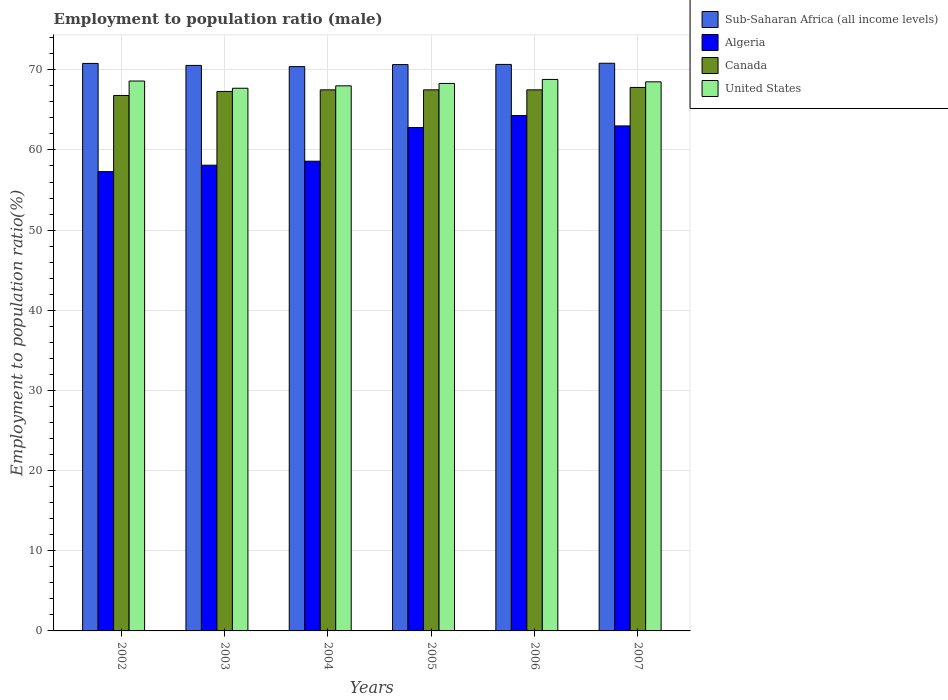How many different coloured bars are there?
Keep it short and to the point. 4. How many groups of bars are there?
Keep it short and to the point. 6. Are the number of bars on each tick of the X-axis equal?
Provide a short and direct response. Yes. How many bars are there on the 4th tick from the left?
Offer a very short reply. 4. What is the label of the 4th group of bars from the left?
Ensure brevity in your answer.  2005. What is the employment to population ratio in Algeria in 2006?
Provide a short and direct response. 64.3. Across all years, what is the maximum employment to population ratio in United States?
Offer a terse response. 68.8. Across all years, what is the minimum employment to population ratio in Algeria?
Give a very brief answer. 57.3. In which year was the employment to population ratio in United States maximum?
Offer a terse response. 2006. In which year was the employment to population ratio in United States minimum?
Give a very brief answer. 2003. What is the total employment to population ratio in Sub-Saharan Africa (all income levels) in the graph?
Make the answer very short. 423.88. What is the difference between the employment to population ratio in Sub-Saharan Africa (all income levels) in 2002 and that in 2007?
Give a very brief answer. -0.02. What is the difference between the employment to population ratio in Sub-Saharan Africa (all income levels) in 2007 and the employment to population ratio in Algeria in 2004?
Your answer should be very brief. 12.22. What is the average employment to population ratio in United States per year?
Make the answer very short. 68.32. In the year 2006, what is the difference between the employment to population ratio in United States and employment to population ratio in Canada?
Offer a terse response. 1.3. In how many years, is the employment to population ratio in Canada greater than 32 %?
Provide a succinct answer. 6. What is the ratio of the employment to population ratio in Sub-Saharan Africa (all income levels) in 2004 to that in 2007?
Offer a terse response. 0.99. Is the employment to population ratio in United States in 2005 less than that in 2007?
Your answer should be compact. Yes. What is the difference between the highest and the second highest employment to population ratio in Algeria?
Ensure brevity in your answer.  1.3. What is the difference between the highest and the lowest employment to population ratio in United States?
Offer a terse response. 1.1. Is the sum of the employment to population ratio in Canada in 2002 and 2005 greater than the maximum employment to population ratio in Sub-Saharan Africa (all income levels) across all years?
Provide a succinct answer. Yes. Is it the case that in every year, the sum of the employment to population ratio in Sub-Saharan Africa (all income levels) and employment to population ratio in Algeria is greater than the sum of employment to population ratio in United States and employment to population ratio in Canada?
Provide a short and direct response. No. Is it the case that in every year, the sum of the employment to population ratio in Sub-Saharan Africa (all income levels) and employment to population ratio in Canada is greater than the employment to population ratio in Algeria?
Your answer should be compact. Yes. What is the difference between two consecutive major ticks on the Y-axis?
Your response must be concise. 10. Does the graph contain any zero values?
Offer a terse response. No. Where does the legend appear in the graph?
Offer a very short reply. Top right. How many legend labels are there?
Ensure brevity in your answer.  4. What is the title of the graph?
Offer a terse response. Employment to population ratio (male). What is the label or title of the X-axis?
Your answer should be very brief. Years. What is the label or title of the Y-axis?
Offer a very short reply. Employment to population ratio(%). What is the Employment to population ratio(%) in Sub-Saharan Africa (all income levels) in 2002?
Provide a short and direct response. 70.8. What is the Employment to population ratio(%) in Algeria in 2002?
Offer a terse response. 57.3. What is the Employment to population ratio(%) of Canada in 2002?
Offer a terse response. 66.8. What is the Employment to population ratio(%) in United States in 2002?
Provide a short and direct response. 68.6. What is the Employment to population ratio(%) of Sub-Saharan Africa (all income levels) in 2003?
Ensure brevity in your answer.  70.55. What is the Employment to population ratio(%) in Algeria in 2003?
Make the answer very short. 58.1. What is the Employment to population ratio(%) in Canada in 2003?
Provide a short and direct response. 67.3. What is the Employment to population ratio(%) in United States in 2003?
Offer a terse response. 67.7. What is the Employment to population ratio(%) in Sub-Saharan Africa (all income levels) in 2004?
Give a very brief answer. 70.4. What is the Employment to population ratio(%) of Algeria in 2004?
Give a very brief answer. 58.6. What is the Employment to population ratio(%) in Canada in 2004?
Offer a very short reply. 67.5. What is the Employment to population ratio(%) of United States in 2004?
Keep it short and to the point. 68. What is the Employment to population ratio(%) of Sub-Saharan Africa (all income levels) in 2005?
Provide a short and direct response. 70.65. What is the Employment to population ratio(%) in Algeria in 2005?
Offer a very short reply. 62.8. What is the Employment to population ratio(%) of Canada in 2005?
Offer a very short reply. 67.5. What is the Employment to population ratio(%) in United States in 2005?
Make the answer very short. 68.3. What is the Employment to population ratio(%) of Sub-Saharan Africa (all income levels) in 2006?
Provide a succinct answer. 70.67. What is the Employment to population ratio(%) in Algeria in 2006?
Ensure brevity in your answer.  64.3. What is the Employment to population ratio(%) in Canada in 2006?
Offer a very short reply. 67.5. What is the Employment to population ratio(%) of United States in 2006?
Offer a very short reply. 68.8. What is the Employment to population ratio(%) in Sub-Saharan Africa (all income levels) in 2007?
Your response must be concise. 70.82. What is the Employment to population ratio(%) in Algeria in 2007?
Your answer should be compact. 63. What is the Employment to population ratio(%) of Canada in 2007?
Give a very brief answer. 67.8. What is the Employment to population ratio(%) of United States in 2007?
Your answer should be compact. 68.5. Across all years, what is the maximum Employment to population ratio(%) of Sub-Saharan Africa (all income levels)?
Provide a succinct answer. 70.82. Across all years, what is the maximum Employment to population ratio(%) of Algeria?
Your answer should be very brief. 64.3. Across all years, what is the maximum Employment to population ratio(%) of Canada?
Your answer should be compact. 67.8. Across all years, what is the maximum Employment to population ratio(%) in United States?
Offer a very short reply. 68.8. Across all years, what is the minimum Employment to population ratio(%) of Sub-Saharan Africa (all income levels)?
Provide a short and direct response. 70.4. Across all years, what is the minimum Employment to population ratio(%) in Algeria?
Make the answer very short. 57.3. Across all years, what is the minimum Employment to population ratio(%) in Canada?
Your response must be concise. 66.8. Across all years, what is the minimum Employment to population ratio(%) in United States?
Give a very brief answer. 67.7. What is the total Employment to population ratio(%) in Sub-Saharan Africa (all income levels) in the graph?
Provide a short and direct response. 423.88. What is the total Employment to population ratio(%) in Algeria in the graph?
Make the answer very short. 364.1. What is the total Employment to population ratio(%) in Canada in the graph?
Your answer should be very brief. 404.4. What is the total Employment to population ratio(%) in United States in the graph?
Give a very brief answer. 409.9. What is the difference between the Employment to population ratio(%) in Sub-Saharan Africa (all income levels) in 2002 and that in 2003?
Your answer should be compact. 0.25. What is the difference between the Employment to population ratio(%) of Canada in 2002 and that in 2003?
Provide a succinct answer. -0.5. What is the difference between the Employment to population ratio(%) in Sub-Saharan Africa (all income levels) in 2002 and that in 2004?
Your response must be concise. 0.4. What is the difference between the Employment to population ratio(%) of United States in 2002 and that in 2004?
Offer a terse response. 0.6. What is the difference between the Employment to population ratio(%) of Sub-Saharan Africa (all income levels) in 2002 and that in 2005?
Your answer should be compact. 0.14. What is the difference between the Employment to population ratio(%) of Algeria in 2002 and that in 2005?
Give a very brief answer. -5.5. What is the difference between the Employment to population ratio(%) of Canada in 2002 and that in 2005?
Provide a succinct answer. -0.7. What is the difference between the Employment to population ratio(%) in United States in 2002 and that in 2005?
Your answer should be very brief. 0.3. What is the difference between the Employment to population ratio(%) of Sub-Saharan Africa (all income levels) in 2002 and that in 2006?
Your response must be concise. 0.12. What is the difference between the Employment to population ratio(%) in Sub-Saharan Africa (all income levels) in 2002 and that in 2007?
Give a very brief answer. -0.02. What is the difference between the Employment to population ratio(%) in Algeria in 2002 and that in 2007?
Give a very brief answer. -5.7. What is the difference between the Employment to population ratio(%) of Canada in 2002 and that in 2007?
Provide a succinct answer. -1. What is the difference between the Employment to population ratio(%) of Canada in 2003 and that in 2004?
Keep it short and to the point. -0.2. What is the difference between the Employment to population ratio(%) in Sub-Saharan Africa (all income levels) in 2003 and that in 2005?
Keep it short and to the point. -0.1. What is the difference between the Employment to population ratio(%) of Sub-Saharan Africa (all income levels) in 2003 and that in 2006?
Your answer should be compact. -0.12. What is the difference between the Employment to population ratio(%) of Algeria in 2003 and that in 2006?
Ensure brevity in your answer.  -6.2. What is the difference between the Employment to population ratio(%) of Sub-Saharan Africa (all income levels) in 2003 and that in 2007?
Offer a terse response. -0.27. What is the difference between the Employment to population ratio(%) of Algeria in 2003 and that in 2007?
Your response must be concise. -4.9. What is the difference between the Employment to population ratio(%) in Canada in 2003 and that in 2007?
Provide a short and direct response. -0.5. What is the difference between the Employment to population ratio(%) of Sub-Saharan Africa (all income levels) in 2004 and that in 2005?
Your response must be concise. -0.25. What is the difference between the Employment to population ratio(%) in Algeria in 2004 and that in 2005?
Ensure brevity in your answer.  -4.2. What is the difference between the Employment to population ratio(%) in United States in 2004 and that in 2005?
Offer a very short reply. -0.3. What is the difference between the Employment to population ratio(%) of Sub-Saharan Africa (all income levels) in 2004 and that in 2006?
Provide a short and direct response. -0.27. What is the difference between the Employment to population ratio(%) in Algeria in 2004 and that in 2006?
Offer a terse response. -5.7. What is the difference between the Employment to population ratio(%) of Canada in 2004 and that in 2006?
Provide a short and direct response. 0. What is the difference between the Employment to population ratio(%) in United States in 2004 and that in 2006?
Keep it short and to the point. -0.8. What is the difference between the Employment to population ratio(%) of Sub-Saharan Africa (all income levels) in 2004 and that in 2007?
Keep it short and to the point. -0.42. What is the difference between the Employment to population ratio(%) in Algeria in 2004 and that in 2007?
Give a very brief answer. -4.4. What is the difference between the Employment to population ratio(%) in Canada in 2004 and that in 2007?
Give a very brief answer. -0.3. What is the difference between the Employment to population ratio(%) in United States in 2004 and that in 2007?
Offer a very short reply. -0.5. What is the difference between the Employment to population ratio(%) of Sub-Saharan Africa (all income levels) in 2005 and that in 2006?
Your answer should be compact. -0.02. What is the difference between the Employment to population ratio(%) in Algeria in 2005 and that in 2006?
Give a very brief answer. -1.5. What is the difference between the Employment to population ratio(%) in United States in 2005 and that in 2006?
Keep it short and to the point. -0.5. What is the difference between the Employment to population ratio(%) in Sub-Saharan Africa (all income levels) in 2005 and that in 2007?
Make the answer very short. -0.17. What is the difference between the Employment to population ratio(%) in Sub-Saharan Africa (all income levels) in 2006 and that in 2007?
Provide a short and direct response. -0.15. What is the difference between the Employment to population ratio(%) of Canada in 2006 and that in 2007?
Keep it short and to the point. -0.3. What is the difference between the Employment to population ratio(%) in United States in 2006 and that in 2007?
Your answer should be very brief. 0.3. What is the difference between the Employment to population ratio(%) in Sub-Saharan Africa (all income levels) in 2002 and the Employment to population ratio(%) in Algeria in 2003?
Ensure brevity in your answer.  12.7. What is the difference between the Employment to population ratio(%) in Sub-Saharan Africa (all income levels) in 2002 and the Employment to population ratio(%) in Canada in 2003?
Offer a very short reply. 3.5. What is the difference between the Employment to population ratio(%) in Sub-Saharan Africa (all income levels) in 2002 and the Employment to population ratio(%) in United States in 2003?
Provide a short and direct response. 3.1. What is the difference between the Employment to population ratio(%) of Canada in 2002 and the Employment to population ratio(%) of United States in 2003?
Ensure brevity in your answer.  -0.9. What is the difference between the Employment to population ratio(%) of Sub-Saharan Africa (all income levels) in 2002 and the Employment to population ratio(%) of Algeria in 2004?
Your answer should be very brief. 12.2. What is the difference between the Employment to population ratio(%) of Sub-Saharan Africa (all income levels) in 2002 and the Employment to population ratio(%) of Canada in 2004?
Provide a succinct answer. 3.3. What is the difference between the Employment to population ratio(%) in Sub-Saharan Africa (all income levels) in 2002 and the Employment to population ratio(%) in United States in 2004?
Offer a very short reply. 2.8. What is the difference between the Employment to population ratio(%) in Canada in 2002 and the Employment to population ratio(%) in United States in 2004?
Offer a very short reply. -1.2. What is the difference between the Employment to population ratio(%) in Sub-Saharan Africa (all income levels) in 2002 and the Employment to population ratio(%) in Algeria in 2005?
Your answer should be compact. 8. What is the difference between the Employment to population ratio(%) of Sub-Saharan Africa (all income levels) in 2002 and the Employment to population ratio(%) of Canada in 2005?
Keep it short and to the point. 3.3. What is the difference between the Employment to population ratio(%) in Sub-Saharan Africa (all income levels) in 2002 and the Employment to population ratio(%) in United States in 2005?
Your response must be concise. 2.5. What is the difference between the Employment to population ratio(%) in Algeria in 2002 and the Employment to population ratio(%) in Canada in 2005?
Give a very brief answer. -10.2. What is the difference between the Employment to population ratio(%) of Algeria in 2002 and the Employment to population ratio(%) of United States in 2005?
Provide a short and direct response. -11. What is the difference between the Employment to population ratio(%) of Canada in 2002 and the Employment to population ratio(%) of United States in 2005?
Ensure brevity in your answer.  -1.5. What is the difference between the Employment to population ratio(%) in Sub-Saharan Africa (all income levels) in 2002 and the Employment to population ratio(%) in Algeria in 2006?
Your response must be concise. 6.5. What is the difference between the Employment to population ratio(%) in Sub-Saharan Africa (all income levels) in 2002 and the Employment to population ratio(%) in Canada in 2006?
Make the answer very short. 3.3. What is the difference between the Employment to population ratio(%) in Sub-Saharan Africa (all income levels) in 2002 and the Employment to population ratio(%) in United States in 2006?
Offer a very short reply. 2. What is the difference between the Employment to population ratio(%) in Algeria in 2002 and the Employment to population ratio(%) in Canada in 2006?
Your response must be concise. -10.2. What is the difference between the Employment to population ratio(%) of Canada in 2002 and the Employment to population ratio(%) of United States in 2006?
Give a very brief answer. -2. What is the difference between the Employment to population ratio(%) of Sub-Saharan Africa (all income levels) in 2002 and the Employment to population ratio(%) of Algeria in 2007?
Provide a succinct answer. 7.8. What is the difference between the Employment to population ratio(%) in Sub-Saharan Africa (all income levels) in 2002 and the Employment to population ratio(%) in Canada in 2007?
Offer a terse response. 3. What is the difference between the Employment to population ratio(%) in Sub-Saharan Africa (all income levels) in 2002 and the Employment to population ratio(%) in United States in 2007?
Your answer should be compact. 2.3. What is the difference between the Employment to population ratio(%) in Algeria in 2002 and the Employment to population ratio(%) in Canada in 2007?
Keep it short and to the point. -10.5. What is the difference between the Employment to population ratio(%) of Canada in 2002 and the Employment to population ratio(%) of United States in 2007?
Your answer should be very brief. -1.7. What is the difference between the Employment to population ratio(%) of Sub-Saharan Africa (all income levels) in 2003 and the Employment to population ratio(%) of Algeria in 2004?
Your answer should be very brief. 11.95. What is the difference between the Employment to population ratio(%) of Sub-Saharan Africa (all income levels) in 2003 and the Employment to population ratio(%) of Canada in 2004?
Make the answer very short. 3.05. What is the difference between the Employment to population ratio(%) of Sub-Saharan Africa (all income levels) in 2003 and the Employment to population ratio(%) of United States in 2004?
Keep it short and to the point. 2.55. What is the difference between the Employment to population ratio(%) in Algeria in 2003 and the Employment to population ratio(%) in Canada in 2004?
Your answer should be very brief. -9.4. What is the difference between the Employment to population ratio(%) of Canada in 2003 and the Employment to population ratio(%) of United States in 2004?
Offer a terse response. -0.7. What is the difference between the Employment to population ratio(%) of Sub-Saharan Africa (all income levels) in 2003 and the Employment to population ratio(%) of Algeria in 2005?
Your answer should be very brief. 7.75. What is the difference between the Employment to population ratio(%) of Sub-Saharan Africa (all income levels) in 2003 and the Employment to population ratio(%) of Canada in 2005?
Your answer should be very brief. 3.05. What is the difference between the Employment to population ratio(%) of Sub-Saharan Africa (all income levels) in 2003 and the Employment to population ratio(%) of United States in 2005?
Provide a succinct answer. 2.25. What is the difference between the Employment to population ratio(%) of Sub-Saharan Africa (all income levels) in 2003 and the Employment to population ratio(%) of Algeria in 2006?
Your answer should be compact. 6.25. What is the difference between the Employment to population ratio(%) of Sub-Saharan Africa (all income levels) in 2003 and the Employment to population ratio(%) of Canada in 2006?
Your response must be concise. 3.05. What is the difference between the Employment to population ratio(%) in Sub-Saharan Africa (all income levels) in 2003 and the Employment to population ratio(%) in United States in 2006?
Ensure brevity in your answer.  1.75. What is the difference between the Employment to population ratio(%) of Algeria in 2003 and the Employment to population ratio(%) of Canada in 2006?
Give a very brief answer. -9.4. What is the difference between the Employment to population ratio(%) of Algeria in 2003 and the Employment to population ratio(%) of United States in 2006?
Keep it short and to the point. -10.7. What is the difference between the Employment to population ratio(%) in Sub-Saharan Africa (all income levels) in 2003 and the Employment to population ratio(%) in Algeria in 2007?
Provide a short and direct response. 7.55. What is the difference between the Employment to population ratio(%) of Sub-Saharan Africa (all income levels) in 2003 and the Employment to population ratio(%) of Canada in 2007?
Provide a short and direct response. 2.75. What is the difference between the Employment to population ratio(%) of Sub-Saharan Africa (all income levels) in 2003 and the Employment to population ratio(%) of United States in 2007?
Make the answer very short. 2.05. What is the difference between the Employment to population ratio(%) of Canada in 2003 and the Employment to population ratio(%) of United States in 2007?
Your answer should be compact. -1.2. What is the difference between the Employment to population ratio(%) in Sub-Saharan Africa (all income levels) in 2004 and the Employment to population ratio(%) in Algeria in 2005?
Offer a very short reply. 7.6. What is the difference between the Employment to population ratio(%) of Sub-Saharan Africa (all income levels) in 2004 and the Employment to population ratio(%) of Canada in 2005?
Keep it short and to the point. 2.9. What is the difference between the Employment to population ratio(%) in Sub-Saharan Africa (all income levels) in 2004 and the Employment to population ratio(%) in United States in 2005?
Offer a very short reply. 2.1. What is the difference between the Employment to population ratio(%) of Algeria in 2004 and the Employment to population ratio(%) of United States in 2005?
Offer a terse response. -9.7. What is the difference between the Employment to population ratio(%) in Sub-Saharan Africa (all income levels) in 2004 and the Employment to population ratio(%) in Algeria in 2006?
Offer a terse response. 6.1. What is the difference between the Employment to population ratio(%) in Sub-Saharan Africa (all income levels) in 2004 and the Employment to population ratio(%) in Canada in 2006?
Provide a succinct answer. 2.9. What is the difference between the Employment to population ratio(%) in Sub-Saharan Africa (all income levels) in 2004 and the Employment to population ratio(%) in United States in 2006?
Make the answer very short. 1.6. What is the difference between the Employment to population ratio(%) of Algeria in 2004 and the Employment to population ratio(%) of Canada in 2006?
Offer a terse response. -8.9. What is the difference between the Employment to population ratio(%) of Sub-Saharan Africa (all income levels) in 2004 and the Employment to population ratio(%) of Algeria in 2007?
Offer a very short reply. 7.4. What is the difference between the Employment to population ratio(%) of Sub-Saharan Africa (all income levels) in 2004 and the Employment to population ratio(%) of Canada in 2007?
Keep it short and to the point. 2.6. What is the difference between the Employment to population ratio(%) in Sub-Saharan Africa (all income levels) in 2004 and the Employment to population ratio(%) in United States in 2007?
Give a very brief answer. 1.9. What is the difference between the Employment to population ratio(%) in Algeria in 2004 and the Employment to population ratio(%) in Canada in 2007?
Ensure brevity in your answer.  -9.2. What is the difference between the Employment to population ratio(%) in Canada in 2004 and the Employment to population ratio(%) in United States in 2007?
Your answer should be very brief. -1. What is the difference between the Employment to population ratio(%) of Sub-Saharan Africa (all income levels) in 2005 and the Employment to population ratio(%) of Algeria in 2006?
Provide a short and direct response. 6.35. What is the difference between the Employment to population ratio(%) of Sub-Saharan Africa (all income levels) in 2005 and the Employment to population ratio(%) of Canada in 2006?
Ensure brevity in your answer.  3.15. What is the difference between the Employment to population ratio(%) of Sub-Saharan Africa (all income levels) in 2005 and the Employment to population ratio(%) of United States in 2006?
Give a very brief answer. 1.85. What is the difference between the Employment to population ratio(%) in Algeria in 2005 and the Employment to population ratio(%) in Canada in 2006?
Your response must be concise. -4.7. What is the difference between the Employment to population ratio(%) in Sub-Saharan Africa (all income levels) in 2005 and the Employment to population ratio(%) in Algeria in 2007?
Ensure brevity in your answer.  7.65. What is the difference between the Employment to population ratio(%) of Sub-Saharan Africa (all income levels) in 2005 and the Employment to population ratio(%) of Canada in 2007?
Make the answer very short. 2.85. What is the difference between the Employment to population ratio(%) of Sub-Saharan Africa (all income levels) in 2005 and the Employment to population ratio(%) of United States in 2007?
Ensure brevity in your answer.  2.15. What is the difference between the Employment to population ratio(%) in Canada in 2005 and the Employment to population ratio(%) in United States in 2007?
Provide a short and direct response. -1. What is the difference between the Employment to population ratio(%) of Sub-Saharan Africa (all income levels) in 2006 and the Employment to population ratio(%) of Algeria in 2007?
Provide a succinct answer. 7.67. What is the difference between the Employment to population ratio(%) in Sub-Saharan Africa (all income levels) in 2006 and the Employment to population ratio(%) in Canada in 2007?
Offer a very short reply. 2.87. What is the difference between the Employment to population ratio(%) of Sub-Saharan Africa (all income levels) in 2006 and the Employment to population ratio(%) of United States in 2007?
Keep it short and to the point. 2.17. What is the difference between the Employment to population ratio(%) of Algeria in 2006 and the Employment to population ratio(%) of Canada in 2007?
Make the answer very short. -3.5. What is the difference between the Employment to population ratio(%) of Canada in 2006 and the Employment to population ratio(%) of United States in 2007?
Ensure brevity in your answer.  -1. What is the average Employment to population ratio(%) in Sub-Saharan Africa (all income levels) per year?
Provide a short and direct response. 70.65. What is the average Employment to population ratio(%) in Algeria per year?
Your answer should be very brief. 60.68. What is the average Employment to population ratio(%) in Canada per year?
Make the answer very short. 67.4. What is the average Employment to population ratio(%) in United States per year?
Make the answer very short. 68.32. In the year 2002, what is the difference between the Employment to population ratio(%) of Sub-Saharan Africa (all income levels) and Employment to population ratio(%) of Algeria?
Keep it short and to the point. 13.5. In the year 2002, what is the difference between the Employment to population ratio(%) in Sub-Saharan Africa (all income levels) and Employment to population ratio(%) in Canada?
Ensure brevity in your answer.  4. In the year 2002, what is the difference between the Employment to population ratio(%) of Sub-Saharan Africa (all income levels) and Employment to population ratio(%) of United States?
Provide a short and direct response. 2.2. In the year 2002, what is the difference between the Employment to population ratio(%) of Algeria and Employment to population ratio(%) of Canada?
Ensure brevity in your answer.  -9.5. In the year 2002, what is the difference between the Employment to population ratio(%) in Algeria and Employment to population ratio(%) in United States?
Make the answer very short. -11.3. In the year 2002, what is the difference between the Employment to population ratio(%) of Canada and Employment to population ratio(%) of United States?
Provide a succinct answer. -1.8. In the year 2003, what is the difference between the Employment to population ratio(%) of Sub-Saharan Africa (all income levels) and Employment to population ratio(%) of Algeria?
Your answer should be very brief. 12.45. In the year 2003, what is the difference between the Employment to population ratio(%) of Sub-Saharan Africa (all income levels) and Employment to population ratio(%) of Canada?
Offer a terse response. 3.25. In the year 2003, what is the difference between the Employment to population ratio(%) of Sub-Saharan Africa (all income levels) and Employment to population ratio(%) of United States?
Your answer should be very brief. 2.85. In the year 2003, what is the difference between the Employment to population ratio(%) in Algeria and Employment to population ratio(%) in Canada?
Your response must be concise. -9.2. In the year 2004, what is the difference between the Employment to population ratio(%) of Sub-Saharan Africa (all income levels) and Employment to population ratio(%) of Algeria?
Your response must be concise. 11.8. In the year 2004, what is the difference between the Employment to population ratio(%) in Sub-Saharan Africa (all income levels) and Employment to population ratio(%) in Canada?
Offer a terse response. 2.9. In the year 2004, what is the difference between the Employment to population ratio(%) of Sub-Saharan Africa (all income levels) and Employment to population ratio(%) of United States?
Your answer should be very brief. 2.4. In the year 2004, what is the difference between the Employment to population ratio(%) in Algeria and Employment to population ratio(%) in United States?
Provide a succinct answer. -9.4. In the year 2005, what is the difference between the Employment to population ratio(%) in Sub-Saharan Africa (all income levels) and Employment to population ratio(%) in Algeria?
Offer a very short reply. 7.85. In the year 2005, what is the difference between the Employment to population ratio(%) of Sub-Saharan Africa (all income levels) and Employment to population ratio(%) of Canada?
Offer a very short reply. 3.15. In the year 2005, what is the difference between the Employment to population ratio(%) in Sub-Saharan Africa (all income levels) and Employment to population ratio(%) in United States?
Offer a terse response. 2.35. In the year 2005, what is the difference between the Employment to population ratio(%) in Algeria and Employment to population ratio(%) in United States?
Your response must be concise. -5.5. In the year 2005, what is the difference between the Employment to population ratio(%) of Canada and Employment to population ratio(%) of United States?
Give a very brief answer. -0.8. In the year 2006, what is the difference between the Employment to population ratio(%) in Sub-Saharan Africa (all income levels) and Employment to population ratio(%) in Algeria?
Provide a short and direct response. 6.37. In the year 2006, what is the difference between the Employment to population ratio(%) of Sub-Saharan Africa (all income levels) and Employment to population ratio(%) of Canada?
Make the answer very short. 3.17. In the year 2006, what is the difference between the Employment to population ratio(%) in Sub-Saharan Africa (all income levels) and Employment to population ratio(%) in United States?
Your response must be concise. 1.87. In the year 2006, what is the difference between the Employment to population ratio(%) in Algeria and Employment to population ratio(%) in United States?
Your answer should be very brief. -4.5. In the year 2007, what is the difference between the Employment to population ratio(%) in Sub-Saharan Africa (all income levels) and Employment to population ratio(%) in Algeria?
Make the answer very short. 7.82. In the year 2007, what is the difference between the Employment to population ratio(%) of Sub-Saharan Africa (all income levels) and Employment to population ratio(%) of Canada?
Your response must be concise. 3.02. In the year 2007, what is the difference between the Employment to population ratio(%) of Sub-Saharan Africa (all income levels) and Employment to population ratio(%) of United States?
Your answer should be compact. 2.32. In the year 2007, what is the difference between the Employment to population ratio(%) of Canada and Employment to population ratio(%) of United States?
Offer a terse response. -0.7. What is the ratio of the Employment to population ratio(%) in Sub-Saharan Africa (all income levels) in 2002 to that in 2003?
Offer a very short reply. 1. What is the ratio of the Employment to population ratio(%) of Algeria in 2002 to that in 2003?
Keep it short and to the point. 0.99. What is the ratio of the Employment to population ratio(%) of Canada in 2002 to that in 2003?
Provide a short and direct response. 0.99. What is the ratio of the Employment to population ratio(%) of United States in 2002 to that in 2003?
Offer a terse response. 1.01. What is the ratio of the Employment to population ratio(%) of Sub-Saharan Africa (all income levels) in 2002 to that in 2004?
Give a very brief answer. 1.01. What is the ratio of the Employment to population ratio(%) in Algeria in 2002 to that in 2004?
Give a very brief answer. 0.98. What is the ratio of the Employment to population ratio(%) in Canada in 2002 to that in 2004?
Keep it short and to the point. 0.99. What is the ratio of the Employment to population ratio(%) in United States in 2002 to that in 2004?
Your answer should be very brief. 1.01. What is the ratio of the Employment to population ratio(%) of Sub-Saharan Africa (all income levels) in 2002 to that in 2005?
Offer a terse response. 1. What is the ratio of the Employment to population ratio(%) in Algeria in 2002 to that in 2005?
Provide a succinct answer. 0.91. What is the ratio of the Employment to population ratio(%) of Canada in 2002 to that in 2005?
Ensure brevity in your answer.  0.99. What is the ratio of the Employment to population ratio(%) in United States in 2002 to that in 2005?
Make the answer very short. 1. What is the ratio of the Employment to population ratio(%) in Sub-Saharan Africa (all income levels) in 2002 to that in 2006?
Ensure brevity in your answer.  1. What is the ratio of the Employment to population ratio(%) of Algeria in 2002 to that in 2006?
Make the answer very short. 0.89. What is the ratio of the Employment to population ratio(%) of Sub-Saharan Africa (all income levels) in 2002 to that in 2007?
Provide a short and direct response. 1. What is the ratio of the Employment to population ratio(%) in Algeria in 2002 to that in 2007?
Make the answer very short. 0.91. What is the ratio of the Employment to population ratio(%) of Sub-Saharan Africa (all income levels) in 2003 to that in 2004?
Make the answer very short. 1. What is the ratio of the Employment to population ratio(%) in Algeria in 2003 to that in 2005?
Offer a terse response. 0.93. What is the ratio of the Employment to population ratio(%) in Canada in 2003 to that in 2005?
Give a very brief answer. 1. What is the ratio of the Employment to population ratio(%) in United States in 2003 to that in 2005?
Provide a short and direct response. 0.99. What is the ratio of the Employment to population ratio(%) of Sub-Saharan Africa (all income levels) in 2003 to that in 2006?
Your answer should be very brief. 1. What is the ratio of the Employment to population ratio(%) of Algeria in 2003 to that in 2006?
Your answer should be compact. 0.9. What is the ratio of the Employment to population ratio(%) in Canada in 2003 to that in 2006?
Your answer should be very brief. 1. What is the ratio of the Employment to population ratio(%) in Algeria in 2003 to that in 2007?
Keep it short and to the point. 0.92. What is the ratio of the Employment to population ratio(%) of Canada in 2003 to that in 2007?
Give a very brief answer. 0.99. What is the ratio of the Employment to population ratio(%) of United States in 2003 to that in 2007?
Offer a very short reply. 0.99. What is the ratio of the Employment to population ratio(%) in Algeria in 2004 to that in 2005?
Offer a very short reply. 0.93. What is the ratio of the Employment to population ratio(%) in Canada in 2004 to that in 2005?
Ensure brevity in your answer.  1. What is the ratio of the Employment to population ratio(%) of United States in 2004 to that in 2005?
Give a very brief answer. 1. What is the ratio of the Employment to population ratio(%) of Algeria in 2004 to that in 2006?
Your answer should be very brief. 0.91. What is the ratio of the Employment to population ratio(%) of Canada in 2004 to that in 2006?
Your answer should be very brief. 1. What is the ratio of the Employment to population ratio(%) of United States in 2004 to that in 2006?
Your response must be concise. 0.99. What is the ratio of the Employment to population ratio(%) of Algeria in 2004 to that in 2007?
Provide a short and direct response. 0.93. What is the ratio of the Employment to population ratio(%) in Sub-Saharan Africa (all income levels) in 2005 to that in 2006?
Your answer should be compact. 1. What is the ratio of the Employment to population ratio(%) of Algeria in 2005 to that in 2006?
Provide a succinct answer. 0.98. What is the ratio of the Employment to population ratio(%) in United States in 2005 to that in 2006?
Keep it short and to the point. 0.99. What is the ratio of the Employment to population ratio(%) of Sub-Saharan Africa (all income levels) in 2005 to that in 2007?
Your answer should be very brief. 1. What is the ratio of the Employment to population ratio(%) in Algeria in 2005 to that in 2007?
Offer a terse response. 1. What is the ratio of the Employment to population ratio(%) in United States in 2005 to that in 2007?
Offer a very short reply. 1. What is the ratio of the Employment to population ratio(%) in Sub-Saharan Africa (all income levels) in 2006 to that in 2007?
Offer a very short reply. 1. What is the ratio of the Employment to population ratio(%) of Algeria in 2006 to that in 2007?
Your answer should be very brief. 1.02. What is the difference between the highest and the second highest Employment to population ratio(%) in Sub-Saharan Africa (all income levels)?
Your response must be concise. 0.02. What is the difference between the highest and the second highest Employment to population ratio(%) in Canada?
Give a very brief answer. 0.3. What is the difference between the highest and the second highest Employment to population ratio(%) in United States?
Provide a succinct answer. 0.2. What is the difference between the highest and the lowest Employment to population ratio(%) of Sub-Saharan Africa (all income levels)?
Your answer should be very brief. 0.42. 